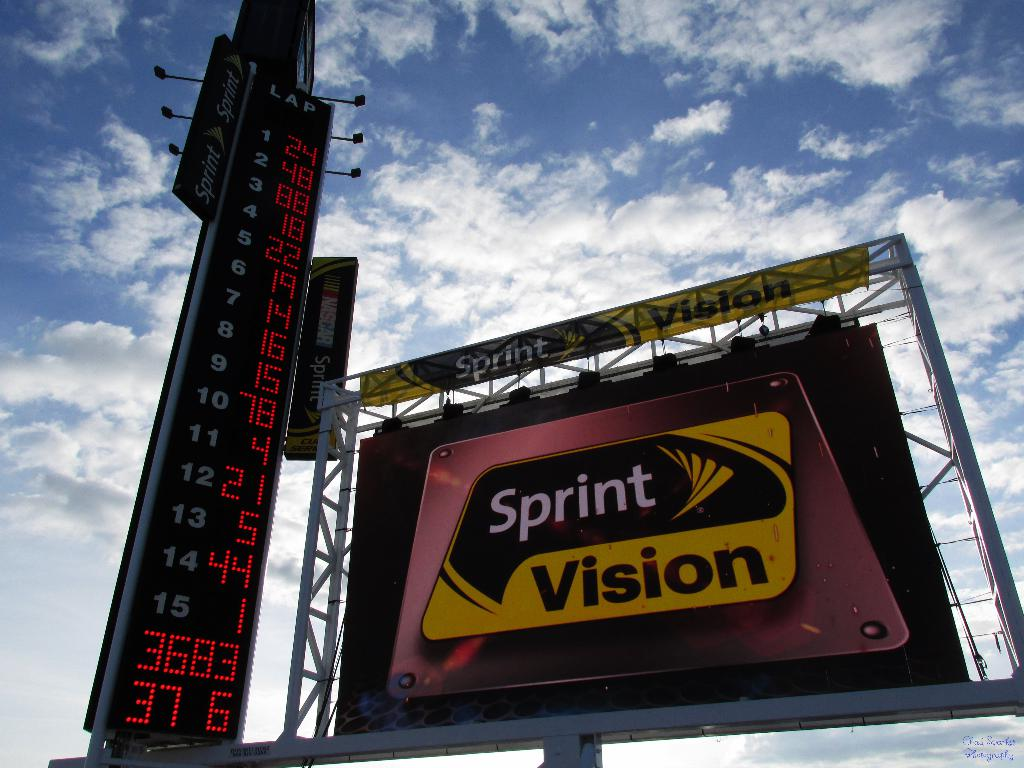What do the numbers on this scoreboard reveal about the progress of the event? The numbers on the scoreboard appear to display sequential timing data, potentially showcasing lap times or race positions. For instance, the first column might be the racer's position, and the subsequent columns could indicate lap times or total elapsed time, providing spectators with real-time updates on each racer's performance during the event. 